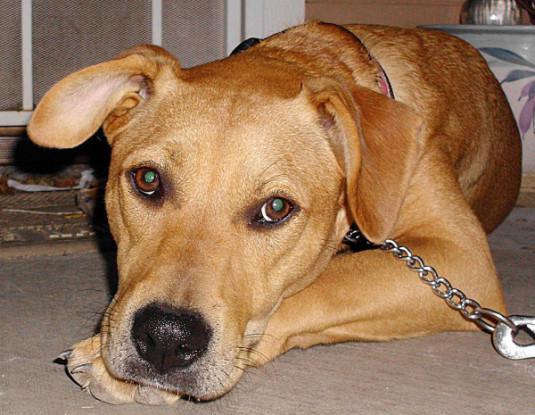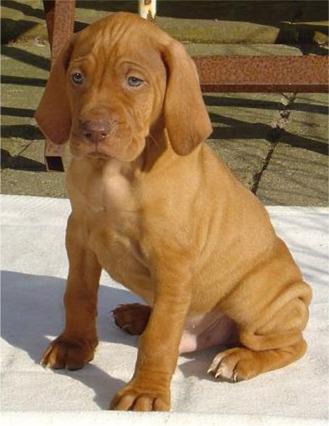The first image is the image on the left, the second image is the image on the right. Considering the images on both sides, is "All the dogs are sitting." valid? Answer yes or no. No. The first image is the image on the left, the second image is the image on the right. For the images shown, is this caption "Each image shows a single red-orange dog sitting upright, and at least one of the dogs depicted is wearing a collar." true? Answer yes or no. No. 